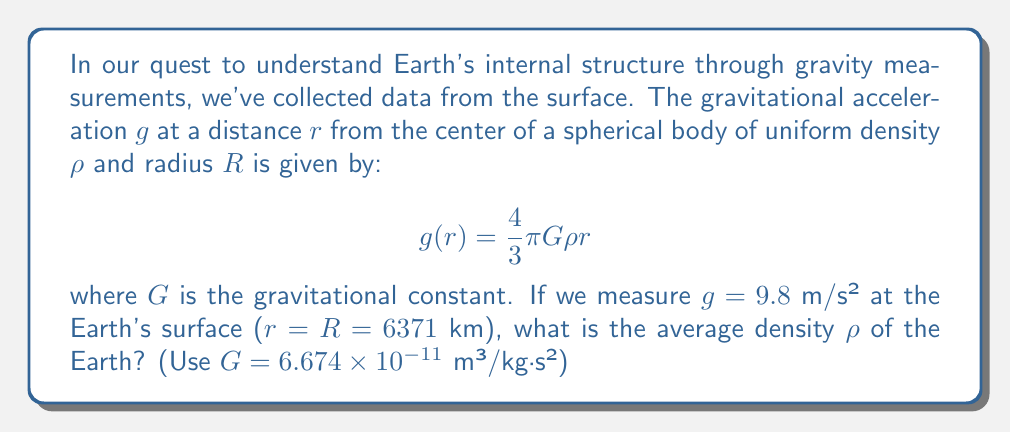Give your solution to this math problem. Let's approach this step-by-step:

1) We start with the given equation:
   $$g(r) = \frac{4}{3}\pi G\rho r$$

2) We know that at the Earth's surface, $r = R = 6371$ km = $6.371 \times 10^6$ m, and $g = 9.8$ m/s².

3) Let's substitute these values into the equation:
   $$9.8 = \frac{4}{3}\pi (6.674 \times 10^{-11}) \rho (6.371 \times 10^6)$$

4) Now, let's solve for $\rho$:
   $$\rho = \frac{9.8}{\frac{4}{3}\pi (6.674 \times 10^{-11}) (6.371 \times 10^6)}$$

5) Let's calculate:
   $$\rho = \frac{9.8}{111.5}$$
   $$\rho = 0.0879 \times 10^3 \text{ kg/m³}$$
   $$\rho = 5.51 \times 10^3 \text{ kg/m³}$$

6) Therefore, the average density of the Earth is approximately 5510 kg/m³.
Answer: 5510 kg/m³ 